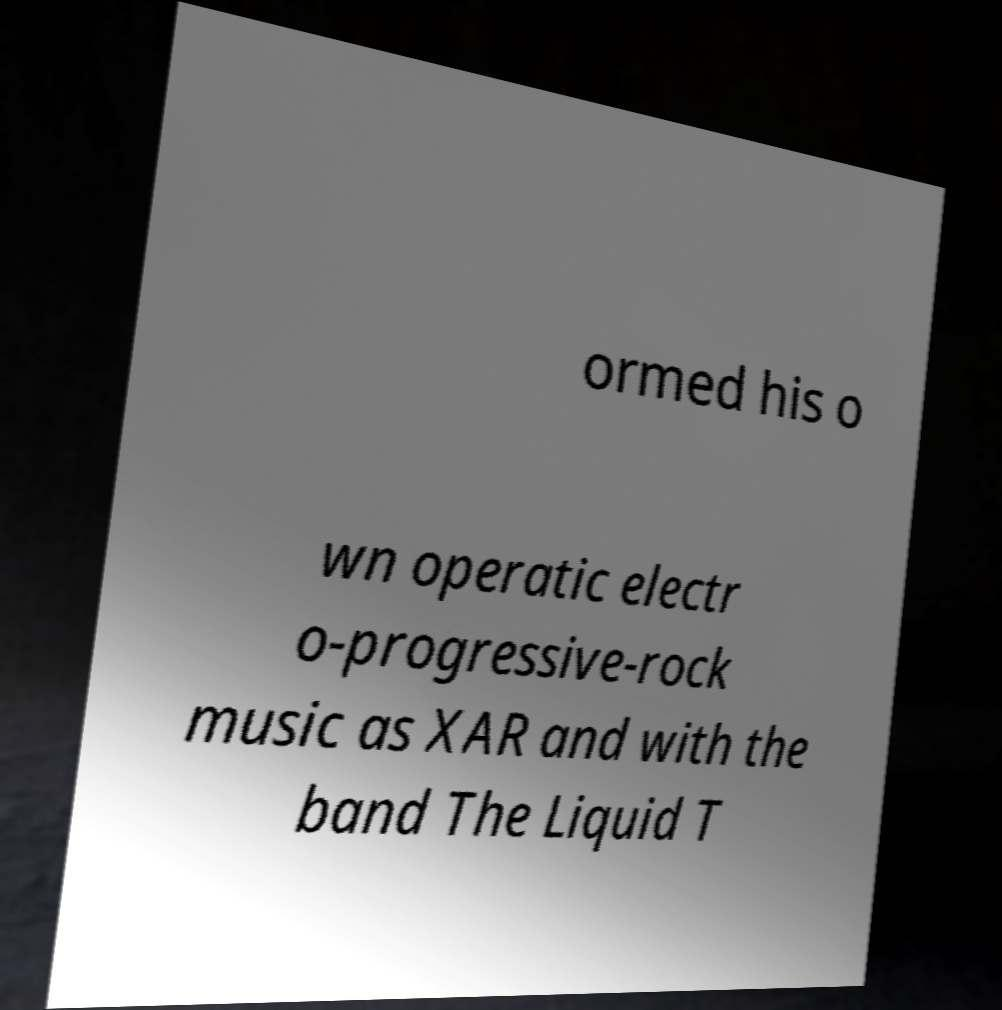Please read and relay the text visible in this image. What does it say? ormed his o wn operatic electr o-progressive-rock music as XAR and with the band The Liquid T 